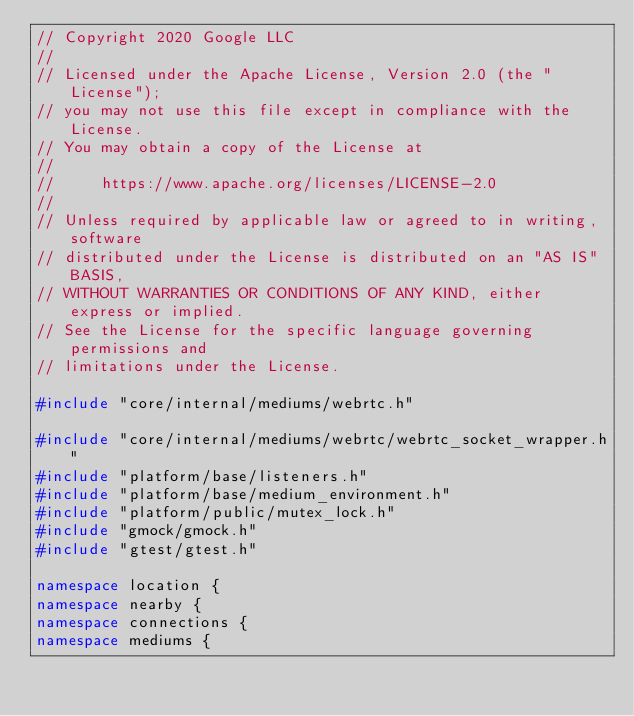Convert code to text. <code><loc_0><loc_0><loc_500><loc_500><_C++_>// Copyright 2020 Google LLC
//
// Licensed under the Apache License, Version 2.0 (the "License");
// you may not use this file except in compliance with the License.
// You may obtain a copy of the License at
//
//     https://www.apache.org/licenses/LICENSE-2.0
//
// Unless required by applicable law or agreed to in writing, software
// distributed under the License is distributed on an "AS IS" BASIS,
// WITHOUT WARRANTIES OR CONDITIONS OF ANY KIND, either express or implied.
// See the License for the specific language governing permissions and
// limitations under the License.

#include "core/internal/mediums/webrtc.h"

#include "core/internal/mediums/webrtc/webrtc_socket_wrapper.h"
#include "platform/base/listeners.h"
#include "platform/base/medium_environment.h"
#include "platform/public/mutex_lock.h"
#include "gmock/gmock.h"
#include "gtest/gtest.h"

namespace location {
namespace nearby {
namespace connections {
namespace mediums {
</code> 